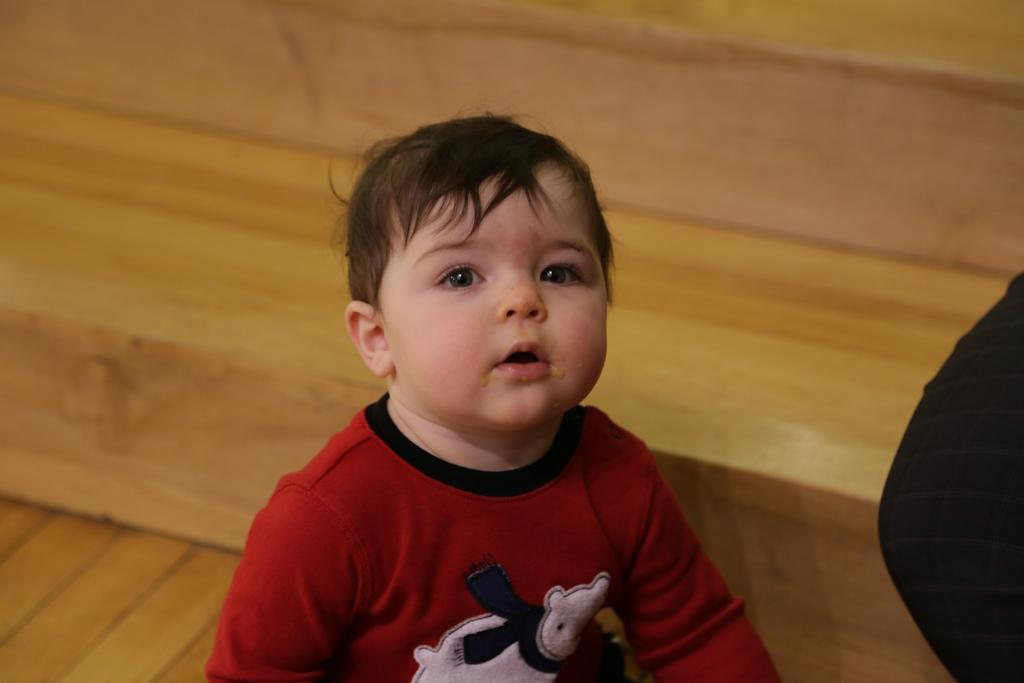Who is the main subject in the image? There is a boy in the image. What can be seen in the background of the image? There is a wooden surface in the background of the image. What is the black object on the right side of the image? Unfortunately, the facts provided do not give enough information to identify the black object on the right side of the image. What type of wealth is the boy displaying in the image? There is no indication of wealth in the image, as it only features a boy and a wooden surface in the background. --- 